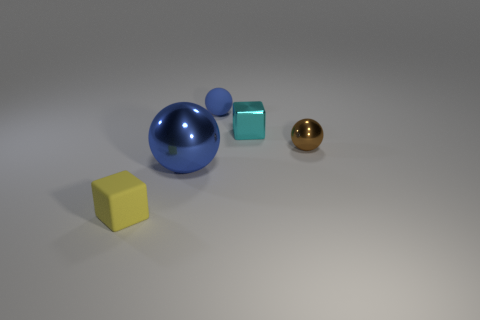There is a yellow thing in front of the brown ball; how many tiny rubber things are behind it?
Ensure brevity in your answer.  1. Is the number of brown metal balls in front of the tiny cyan block less than the number of shiny blocks?
Offer a terse response. No. There is a small rubber thing in front of the blue sphere that is behind the tiny ball right of the blue rubber object; what shape is it?
Keep it short and to the point. Cube. Is the tiny blue rubber thing the same shape as the yellow rubber thing?
Provide a short and direct response. No. How many other things are there of the same shape as the small blue object?
Your answer should be very brief. 2. What color is the other shiny thing that is the same size as the cyan metallic thing?
Offer a terse response. Brown. Are there the same number of blue matte objects that are right of the small brown shiny object and small green cylinders?
Offer a very short reply. Yes. There is a object that is both left of the blue matte object and on the right side of the tiny yellow object; what is its shape?
Ensure brevity in your answer.  Sphere. Does the rubber block have the same size as the rubber sphere?
Provide a succinct answer. Yes. Are there any small objects made of the same material as the big thing?
Give a very brief answer. Yes. 